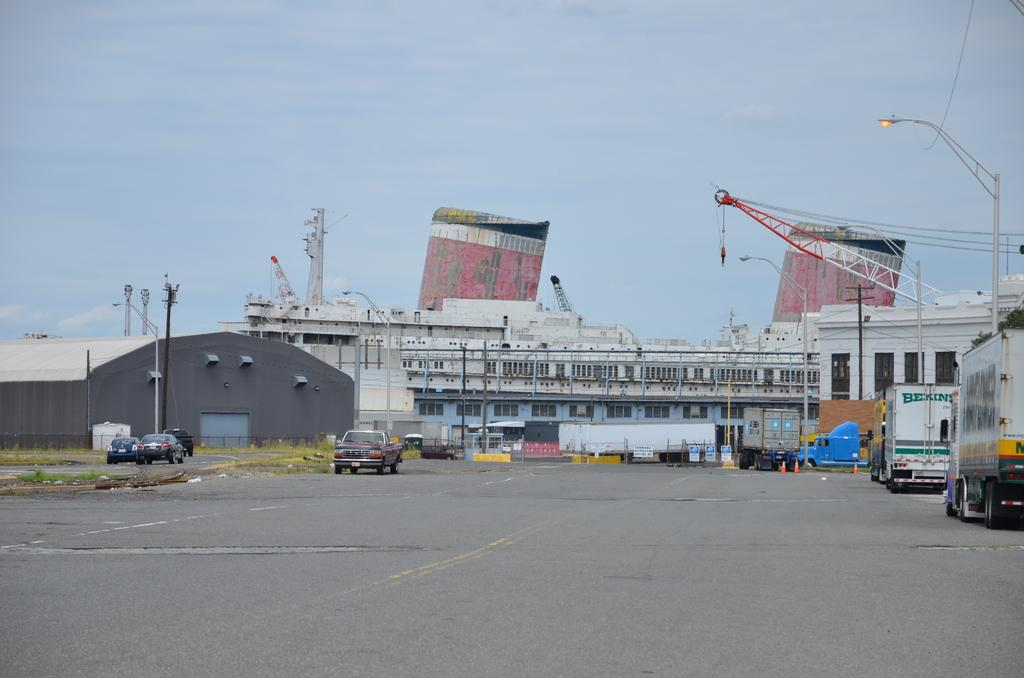What is in the foreground of the image? There is a road in the foreground of the image. What can be seen in the background of the image? There are vehicles, a shed, buildings, and poles in the background of the image. What is visible at the top of the image? The sky is visible at the top of the image. What year is depicted in the image? The image does not depict a specific year; it is a photograph of a scene that could be from any time. Can you locate the area shown in the image using a map? The image does not provide enough information to pinpoint the exact location on a map. 